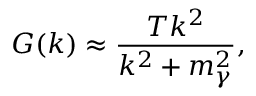<formula> <loc_0><loc_0><loc_500><loc_500>G ( k ) \approx \frac { T k ^ { 2 } } { k ^ { 2 } + m _ { \gamma } ^ { 2 } } ,</formula> 